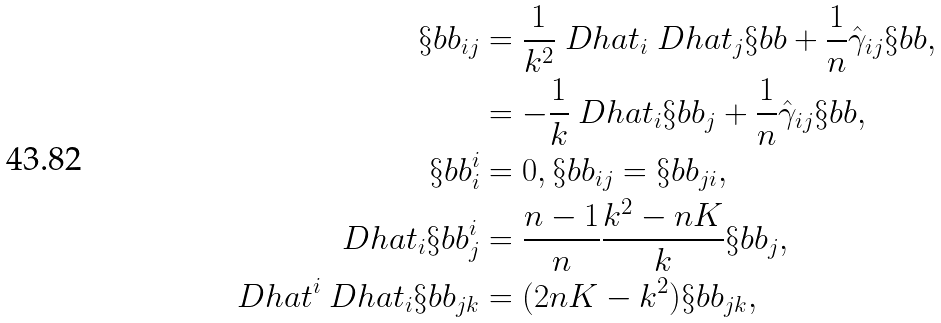Convert formula to latex. <formula><loc_0><loc_0><loc_500><loc_500>\S b b _ { i j } & = \frac { 1 } { k ^ { 2 } } \ D h a t _ { i } \ D h a t _ { j } \S b b + \frac { 1 } { n } \hat { \gamma } _ { i j } \S b b , \\ & = - \frac { 1 } { k } \ D h a t _ { i } \S b b _ { j } + \frac { 1 } { n } \hat { \gamma } _ { i j } \S b b , \\ \S b b ^ { i } _ { i } & = 0 , \S b b _ { i j } = \S b b _ { j i } , \\ \ D h a t _ { i } \S b b ^ { i } _ { j } & = \frac { n - 1 } { n } \frac { k ^ { 2 } - n K } { k } \S b b _ { j } , \\ \ D h a t ^ { i } \ D h a t _ { i } \S b b _ { j k } & = ( 2 n K - k ^ { 2 } ) \S b b _ { j k } ,</formula> 